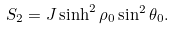Convert formula to latex. <formula><loc_0><loc_0><loc_500><loc_500>S _ { 2 } = J \sinh ^ { 2 } \rho _ { 0 } \sin ^ { 2 } \theta _ { 0 } .</formula> 